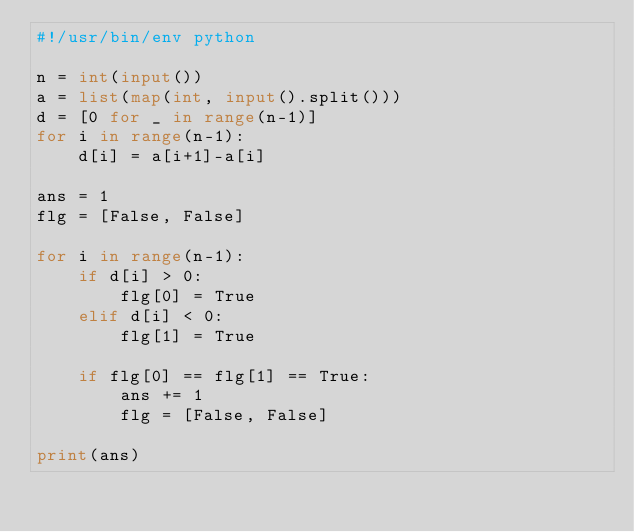Convert code to text. <code><loc_0><loc_0><loc_500><loc_500><_Python_>#!/usr/bin/env python

n = int(input())
a = list(map(int, input().split()))
d = [0 for _ in range(n-1)]
for i in range(n-1):
    d[i] = a[i+1]-a[i]

ans = 1 
flg = [False, False]

for i in range(n-1):
    if d[i] > 0:
        flg[0] = True
    elif d[i] < 0:
        flg[1] = True

    if flg[0] == flg[1] == True:
        ans += 1
        flg = [False, False]

print(ans)
</code> 